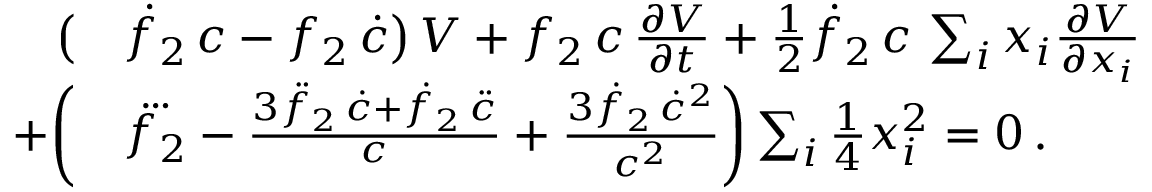Convert formula to latex. <formula><loc_0><loc_0><loc_500><loc_500>\begin{array} { r l } { \left ( } & { \dot { f } _ { 2 } \, c - f _ { 2 } \, \dot { c } \right ) \, V + f _ { 2 } \, c \, \frac { \partial V } { \partial t } + { \frac { 1 } { 2 } } \dot { f } _ { 2 } \, c \, \sum _ { i } x _ { i } \frac { \partial V } { \partial x _ { i } } } \\ { + \left ( } & { \dddot { f _ { 2 } } - \frac { 3 \ddot { f } _ { 2 } \, \dot { c } + \dot { f } _ { 2 } \, \ddot { c } } { c } + \frac { 3 \dot { f } _ { 2 } \, \dot { c } ^ { 2 } } { c ^ { 2 } } \right ) \sum _ { i } { \frac { 1 } { 4 } } x _ { i } ^ { 2 } = 0 \, . } \end{array}</formula> 